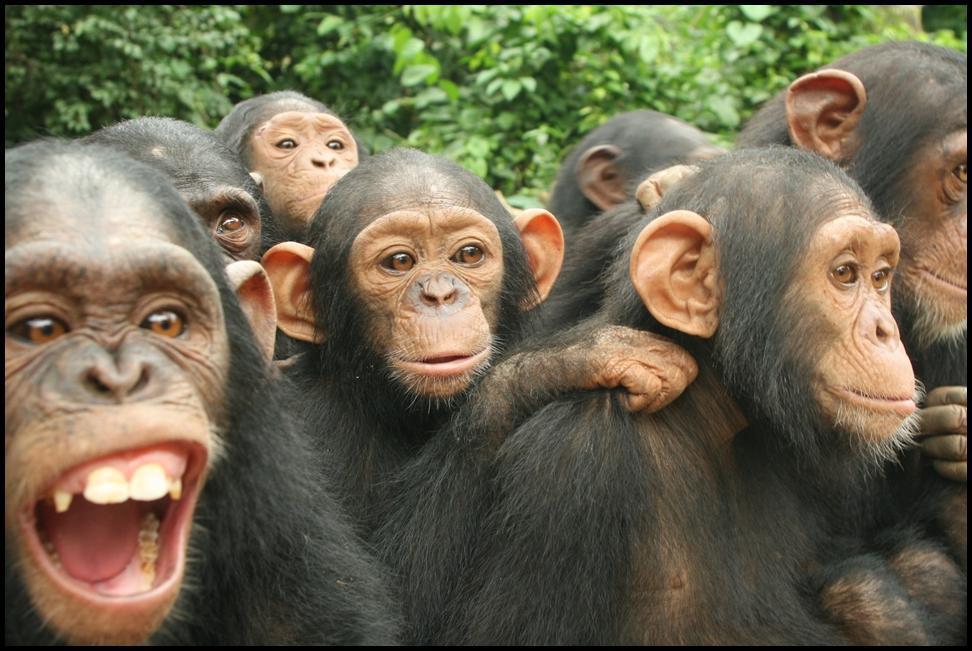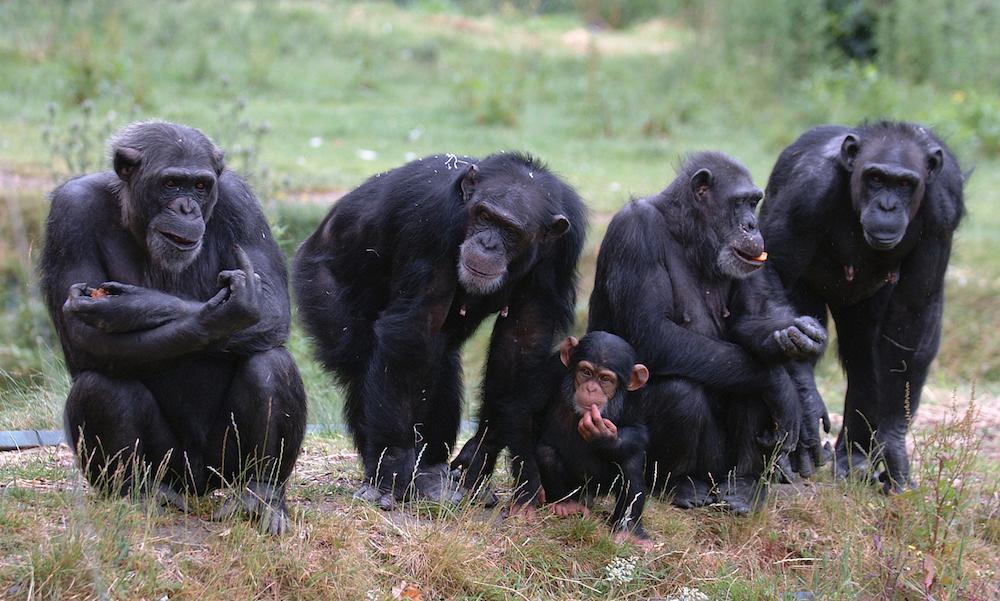The first image is the image on the left, the second image is the image on the right. For the images displayed, is the sentence "An image shows a horizontal row of exactly five chimps." factually correct? Answer yes or no. Yes. 